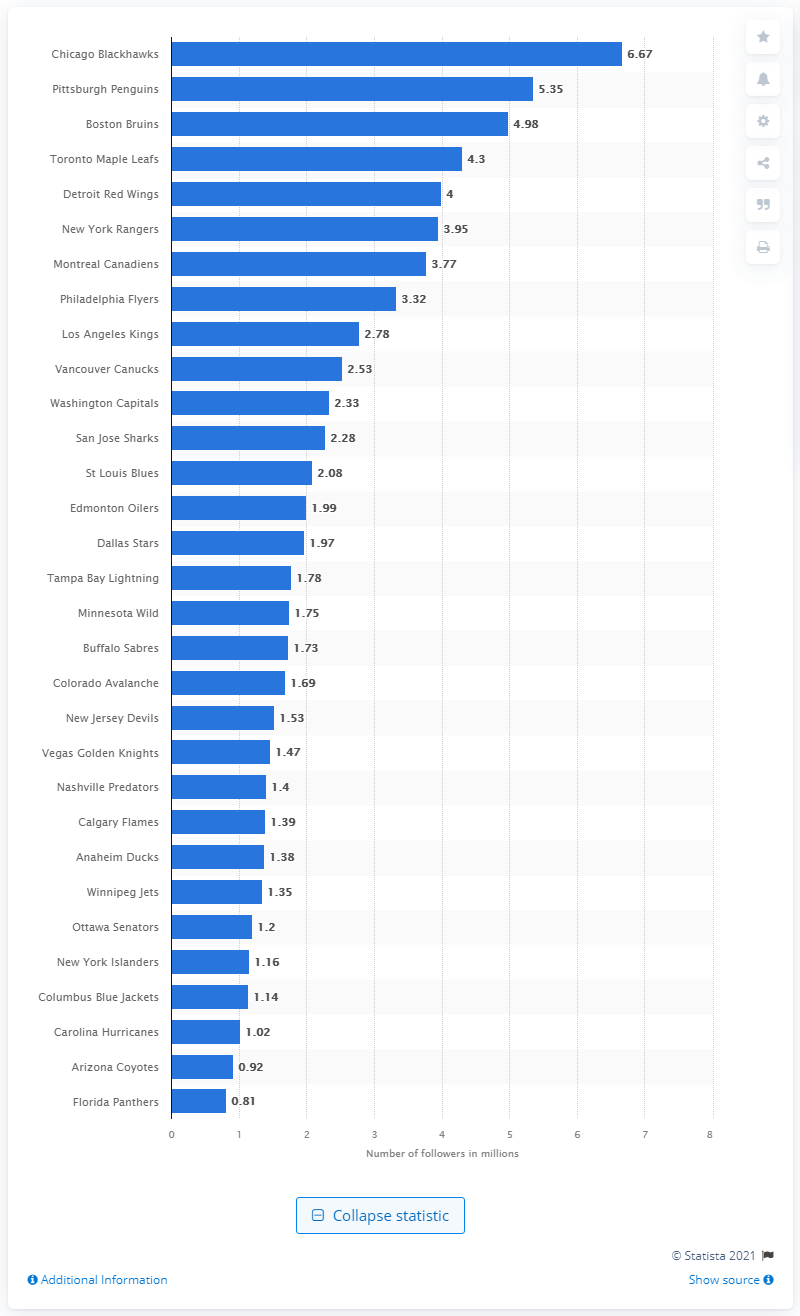Mention a couple of crucial points in this snapshot. In 2019, the Chicago Blackhawks had 6.67 million followers. 